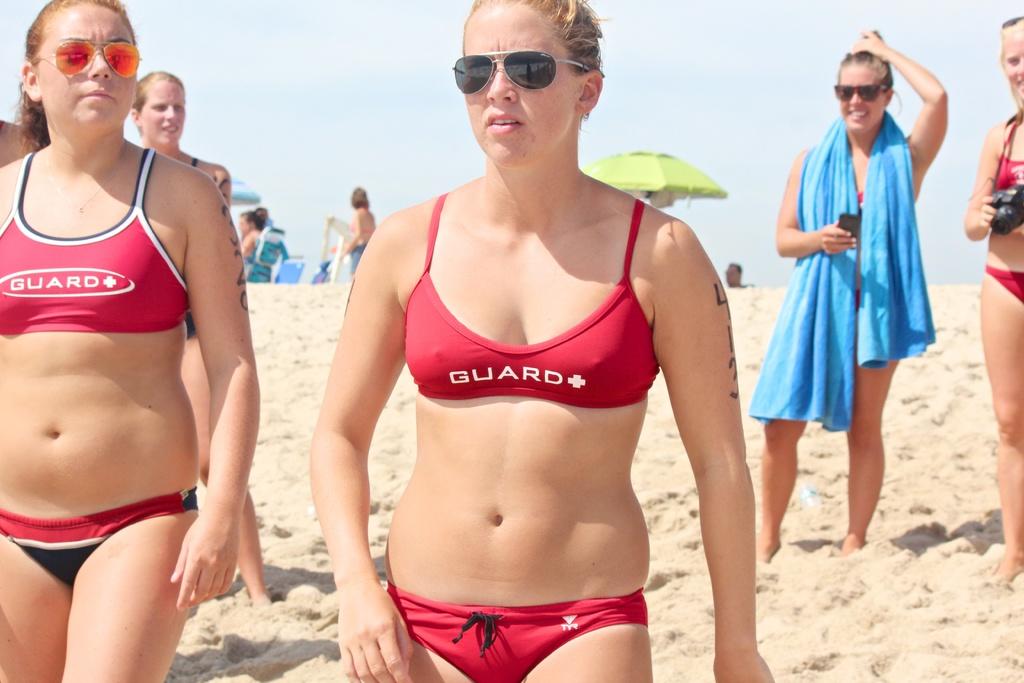What kind of bikini top are these girls wearing?
Give a very brief answer. Guard. 